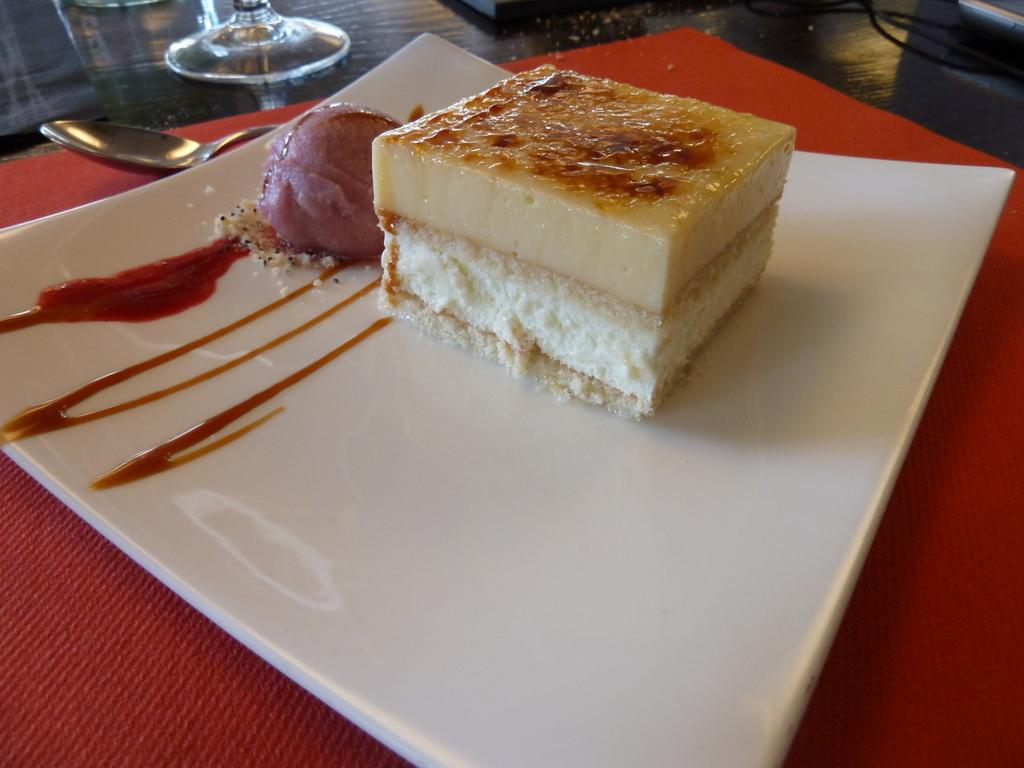What is the main subject in the center of the image? There is a cake on a plate in the center of the image. What else can be seen on the table in the image? There is a spoon and a glass on the table in the image. What type of cork is used to hold the cake in place on the plate? There is no cork present in the image, and the cake is not held in place by any cork. 